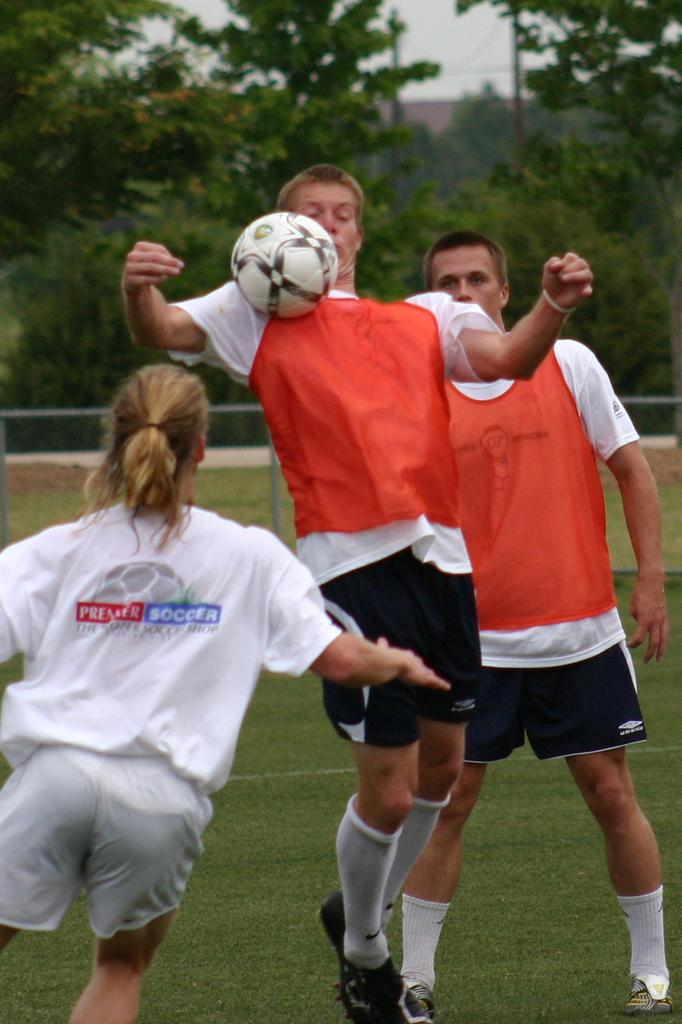How many people are present in the image? There are three individuals in the image, two men and a woman. What activity are the people engaged in? The three individuals are playing football. What can be seen in the background of the image? There are trees and the sky visible in the background of the image. What type of chin can be seen on the geese in the image? There are no geese present in the image, so there is no chin to observe. What type of chess piece is the woman holding in the image? There is no chess piece or any reference to chess in the image; the individuals are playing football. 